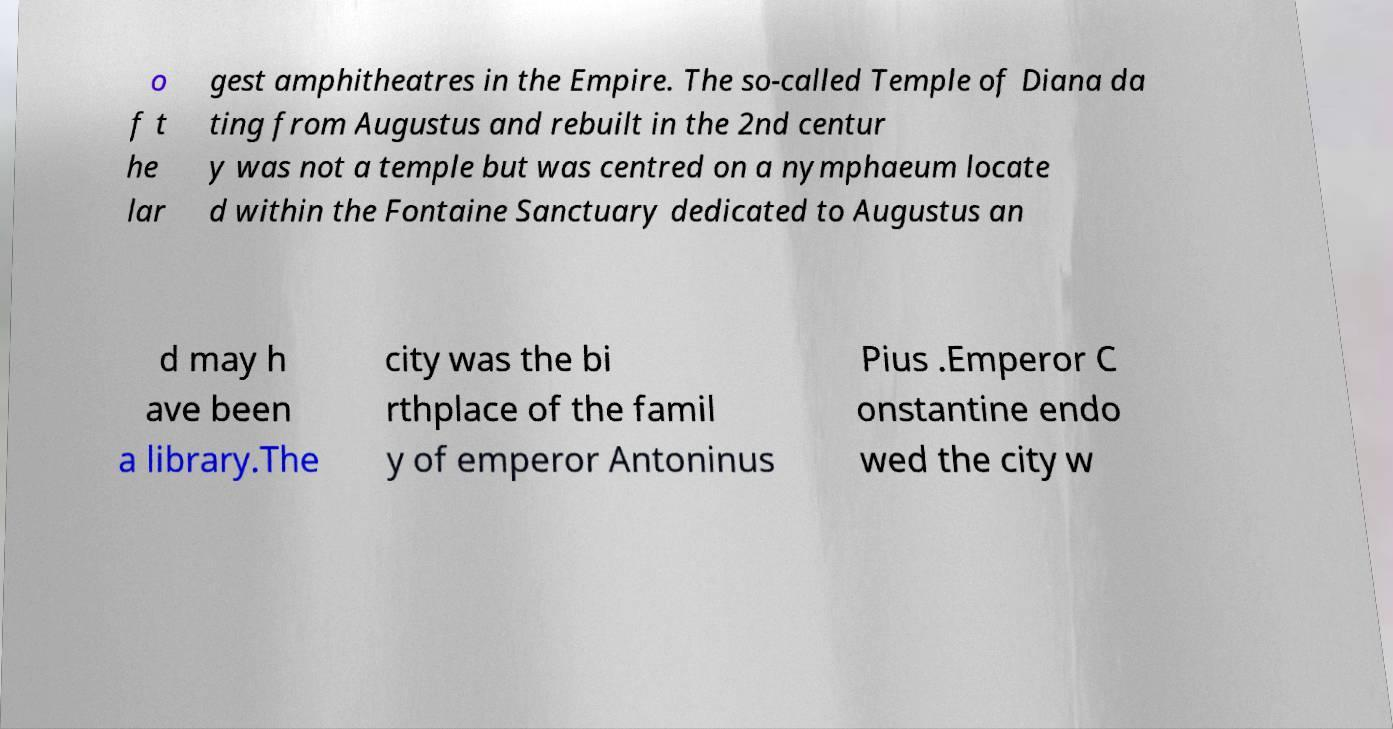I need the written content from this picture converted into text. Can you do that? o f t he lar gest amphitheatres in the Empire. The so-called Temple of Diana da ting from Augustus and rebuilt in the 2nd centur y was not a temple but was centred on a nymphaeum locate d within the Fontaine Sanctuary dedicated to Augustus an d may h ave been a library.The city was the bi rthplace of the famil y of emperor Antoninus Pius .Emperor C onstantine endo wed the city w 